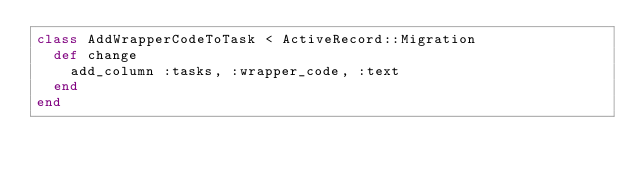<code> <loc_0><loc_0><loc_500><loc_500><_Ruby_>class AddWrapperCodeToTask < ActiveRecord::Migration
  def change
    add_column :tasks, :wrapper_code, :text
  end
end
</code> 